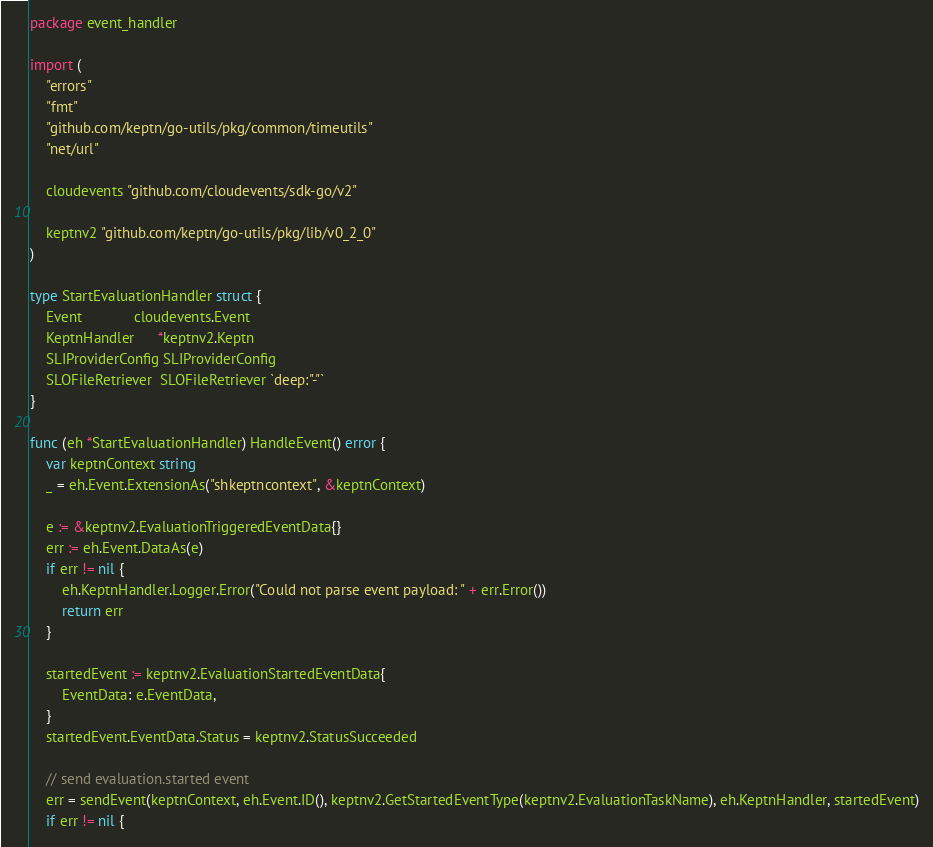<code> <loc_0><loc_0><loc_500><loc_500><_Go_>package event_handler

import (
	"errors"
	"fmt"
	"github.com/keptn/go-utils/pkg/common/timeutils"
	"net/url"

	cloudevents "github.com/cloudevents/sdk-go/v2"

	keptnv2 "github.com/keptn/go-utils/pkg/lib/v0_2_0"
)

type StartEvaluationHandler struct {
	Event             cloudevents.Event
	KeptnHandler      *keptnv2.Keptn
	SLIProviderConfig SLIProviderConfig
	SLOFileRetriever  SLOFileRetriever `deep:"-"`
}

func (eh *StartEvaluationHandler) HandleEvent() error {
	var keptnContext string
	_ = eh.Event.ExtensionAs("shkeptncontext", &keptnContext)

	e := &keptnv2.EvaluationTriggeredEventData{}
	err := eh.Event.DataAs(e)
	if err != nil {
		eh.KeptnHandler.Logger.Error("Could not parse event payload: " + err.Error())
		return err
	}

	startedEvent := keptnv2.EvaluationStartedEventData{
		EventData: e.EventData,
	}
	startedEvent.EventData.Status = keptnv2.StatusSucceeded

	// send evaluation.started event
	err = sendEvent(keptnContext, eh.Event.ID(), keptnv2.GetStartedEventType(keptnv2.EvaluationTaskName), eh.KeptnHandler, startedEvent)
	if err != nil {</code> 